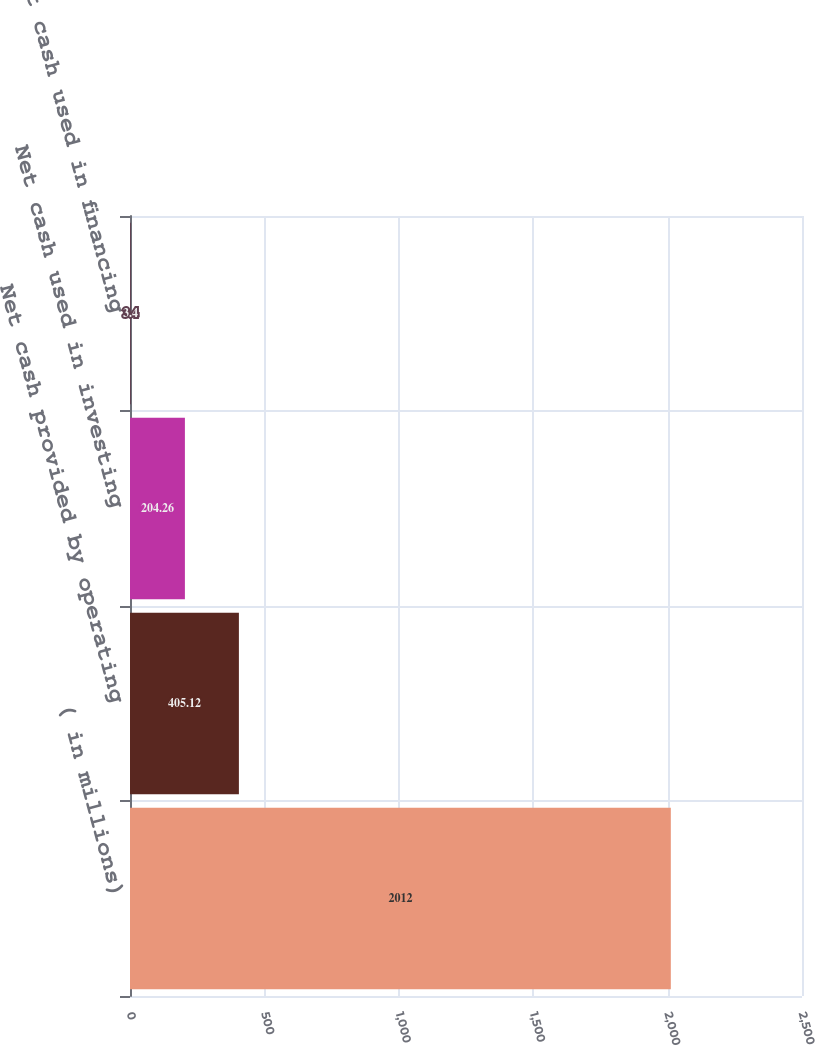Convert chart. <chart><loc_0><loc_0><loc_500><loc_500><bar_chart><fcel>( in millions)<fcel>Net cash provided by operating<fcel>Net cash used in investing<fcel>Net cash used in financing<nl><fcel>2012<fcel>405.12<fcel>204.26<fcel>3.4<nl></chart> 